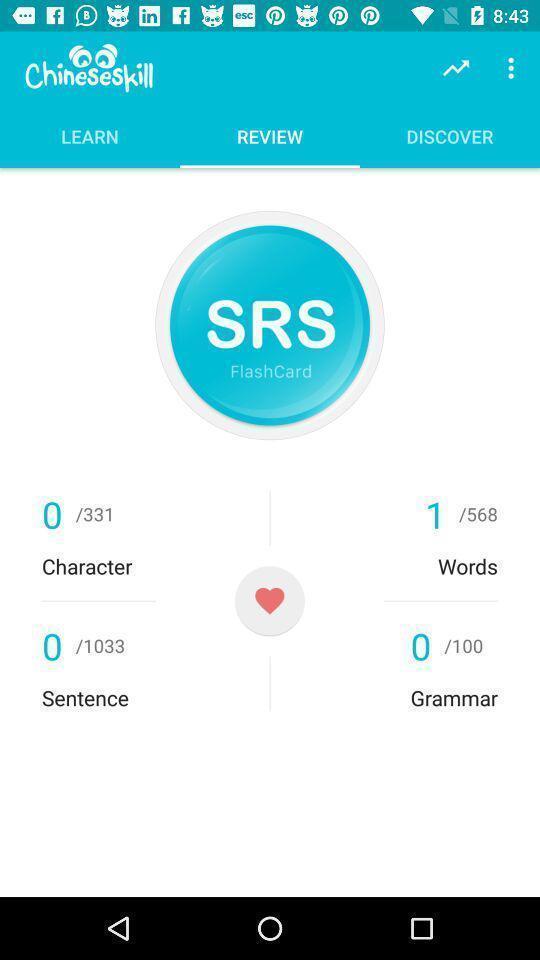Explain the elements present in this screenshot. Review page showing in application. 